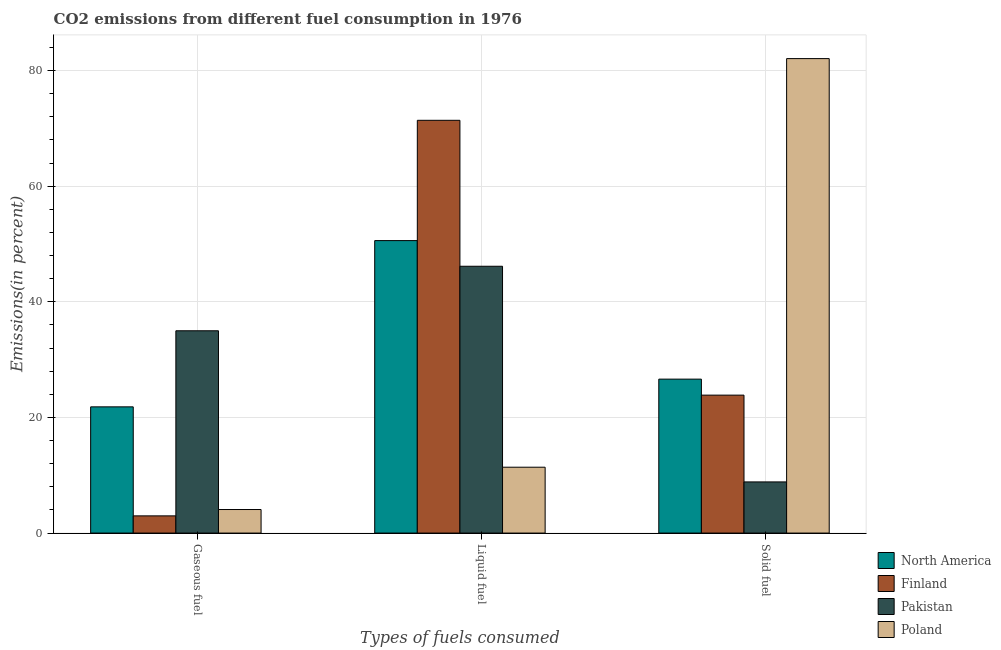Are the number of bars per tick equal to the number of legend labels?
Provide a short and direct response. Yes. What is the label of the 3rd group of bars from the left?
Provide a short and direct response. Solid fuel. What is the percentage of liquid fuel emission in Pakistan?
Keep it short and to the point. 46.15. Across all countries, what is the maximum percentage of solid fuel emission?
Your answer should be very brief. 82.06. Across all countries, what is the minimum percentage of liquid fuel emission?
Give a very brief answer. 11.39. What is the total percentage of gaseous fuel emission in the graph?
Your answer should be compact. 63.87. What is the difference between the percentage of gaseous fuel emission in Finland and that in North America?
Provide a succinct answer. -18.85. What is the difference between the percentage of solid fuel emission in Finland and the percentage of gaseous fuel emission in Poland?
Your response must be concise. 19.78. What is the average percentage of solid fuel emission per country?
Provide a short and direct response. 35.35. What is the difference between the percentage of solid fuel emission and percentage of liquid fuel emission in North America?
Offer a terse response. -23.96. What is the ratio of the percentage of solid fuel emission in Finland to that in Pakistan?
Offer a terse response. 2.7. What is the difference between the highest and the second highest percentage of liquid fuel emission?
Your response must be concise. 20.8. What is the difference between the highest and the lowest percentage of gaseous fuel emission?
Ensure brevity in your answer.  32.01. In how many countries, is the percentage of solid fuel emission greater than the average percentage of solid fuel emission taken over all countries?
Make the answer very short. 1. What does the 3rd bar from the right in Liquid fuel represents?
Keep it short and to the point. Finland. Are the values on the major ticks of Y-axis written in scientific E-notation?
Your answer should be very brief. No. Does the graph contain any zero values?
Provide a succinct answer. No. Does the graph contain grids?
Your answer should be compact. Yes. Where does the legend appear in the graph?
Your response must be concise. Bottom right. What is the title of the graph?
Provide a succinct answer. CO2 emissions from different fuel consumption in 1976. Does "Antigua and Barbuda" appear as one of the legend labels in the graph?
Provide a short and direct response. No. What is the label or title of the X-axis?
Offer a very short reply. Types of fuels consumed. What is the label or title of the Y-axis?
Your answer should be compact. Emissions(in percent). What is the Emissions(in percent) of North America in Gaseous fuel?
Your answer should be compact. 21.83. What is the Emissions(in percent) of Finland in Gaseous fuel?
Your response must be concise. 2.97. What is the Emissions(in percent) of Pakistan in Gaseous fuel?
Make the answer very short. 34.99. What is the Emissions(in percent) of Poland in Gaseous fuel?
Your response must be concise. 4.07. What is the Emissions(in percent) in North America in Liquid fuel?
Your answer should be compact. 50.58. What is the Emissions(in percent) in Finland in Liquid fuel?
Make the answer very short. 71.39. What is the Emissions(in percent) of Pakistan in Liquid fuel?
Your response must be concise. 46.15. What is the Emissions(in percent) of Poland in Liquid fuel?
Give a very brief answer. 11.39. What is the Emissions(in percent) of North America in Solid fuel?
Your answer should be compact. 26.62. What is the Emissions(in percent) in Finland in Solid fuel?
Offer a terse response. 23.86. What is the Emissions(in percent) in Pakistan in Solid fuel?
Your answer should be very brief. 8.85. What is the Emissions(in percent) in Poland in Solid fuel?
Offer a terse response. 82.06. Across all Types of fuels consumed, what is the maximum Emissions(in percent) in North America?
Give a very brief answer. 50.58. Across all Types of fuels consumed, what is the maximum Emissions(in percent) of Finland?
Offer a terse response. 71.39. Across all Types of fuels consumed, what is the maximum Emissions(in percent) of Pakistan?
Provide a succinct answer. 46.15. Across all Types of fuels consumed, what is the maximum Emissions(in percent) of Poland?
Your answer should be compact. 82.06. Across all Types of fuels consumed, what is the minimum Emissions(in percent) of North America?
Provide a succinct answer. 21.83. Across all Types of fuels consumed, what is the minimum Emissions(in percent) of Finland?
Give a very brief answer. 2.97. Across all Types of fuels consumed, what is the minimum Emissions(in percent) in Pakistan?
Offer a terse response. 8.85. Across all Types of fuels consumed, what is the minimum Emissions(in percent) of Poland?
Provide a succinct answer. 4.07. What is the total Emissions(in percent) in North America in the graph?
Your response must be concise. 99.04. What is the total Emissions(in percent) in Finland in the graph?
Offer a very short reply. 98.22. What is the total Emissions(in percent) in Pakistan in the graph?
Your response must be concise. 89.98. What is the total Emissions(in percent) of Poland in the graph?
Offer a terse response. 97.53. What is the difference between the Emissions(in percent) of North America in Gaseous fuel and that in Liquid fuel?
Your answer should be very brief. -28.75. What is the difference between the Emissions(in percent) of Finland in Gaseous fuel and that in Liquid fuel?
Keep it short and to the point. -68.41. What is the difference between the Emissions(in percent) of Pakistan in Gaseous fuel and that in Liquid fuel?
Your answer should be very brief. -11.16. What is the difference between the Emissions(in percent) in Poland in Gaseous fuel and that in Liquid fuel?
Provide a succinct answer. -7.32. What is the difference between the Emissions(in percent) in North America in Gaseous fuel and that in Solid fuel?
Offer a very short reply. -4.79. What is the difference between the Emissions(in percent) of Finland in Gaseous fuel and that in Solid fuel?
Your answer should be very brief. -20.88. What is the difference between the Emissions(in percent) of Pakistan in Gaseous fuel and that in Solid fuel?
Your response must be concise. 26.14. What is the difference between the Emissions(in percent) of Poland in Gaseous fuel and that in Solid fuel?
Keep it short and to the point. -77.99. What is the difference between the Emissions(in percent) of North America in Liquid fuel and that in Solid fuel?
Give a very brief answer. 23.96. What is the difference between the Emissions(in percent) of Finland in Liquid fuel and that in Solid fuel?
Your response must be concise. 47.53. What is the difference between the Emissions(in percent) of Pakistan in Liquid fuel and that in Solid fuel?
Keep it short and to the point. 37.3. What is the difference between the Emissions(in percent) in Poland in Liquid fuel and that in Solid fuel?
Your answer should be very brief. -70.67. What is the difference between the Emissions(in percent) of North America in Gaseous fuel and the Emissions(in percent) of Finland in Liquid fuel?
Your answer should be very brief. -49.56. What is the difference between the Emissions(in percent) of North America in Gaseous fuel and the Emissions(in percent) of Pakistan in Liquid fuel?
Offer a terse response. -24.32. What is the difference between the Emissions(in percent) in North America in Gaseous fuel and the Emissions(in percent) in Poland in Liquid fuel?
Your answer should be compact. 10.44. What is the difference between the Emissions(in percent) in Finland in Gaseous fuel and the Emissions(in percent) in Pakistan in Liquid fuel?
Your answer should be very brief. -43.17. What is the difference between the Emissions(in percent) in Finland in Gaseous fuel and the Emissions(in percent) in Poland in Liquid fuel?
Your answer should be very brief. -8.42. What is the difference between the Emissions(in percent) of Pakistan in Gaseous fuel and the Emissions(in percent) of Poland in Liquid fuel?
Give a very brief answer. 23.6. What is the difference between the Emissions(in percent) in North America in Gaseous fuel and the Emissions(in percent) in Finland in Solid fuel?
Your answer should be compact. -2.03. What is the difference between the Emissions(in percent) of North America in Gaseous fuel and the Emissions(in percent) of Pakistan in Solid fuel?
Give a very brief answer. 12.98. What is the difference between the Emissions(in percent) in North America in Gaseous fuel and the Emissions(in percent) in Poland in Solid fuel?
Offer a terse response. -60.23. What is the difference between the Emissions(in percent) in Finland in Gaseous fuel and the Emissions(in percent) in Pakistan in Solid fuel?
Provide a short and direct response. -5.87. What is the difference between the Emissions(in percent) in Finland in Gaseous fuel and the Emissions(in percent) in Poland in Solid fuel?
Offer a very short reply. -79.09. What is the difference between the Emissions(in percent) in Pakistan in Gaseous fuel and the Emissions(in percent) in Poland in Solid fuel?
Make the answer very short. -47.07. What is the difference between the Emissions(in percent) of North America in Liquid fuel and the Emissions(in percent) of Finland in Solid fuel?
Offer a very short reply. 26.73. What is the difference between the Emissions(in percent) in North America in Liquid fuel and the Emissions(in percent) in Pakistan in Solid fuel?
Make the answer very short. 41.74. What is the difference between the Emissions(in percent) in North America in Liquid fuel and the Emissions(in percent) in Poland in Solid fuel?
Make the answer very short. -31.48. What is the difference between the Emissions(in percent) in Finland in Liquid fuel and the Emissions(in percent) in Pakistan in Solid fuel?
Your response must be concise. 62.54. What is the difference between the Emissions(in percent) of Finland in Liquid fuel and the Emissions(in percent) of Poland in Solid fuel?
Make the answer very short. -10.67. What is the difference between the Emissions(in percent) in Pakistan in Liquid fuel and the Emissions(in percent) in Poland in Solid fuel?
Your answer should be compact. -35.91. What is the average Emissions(in percent) in North America per Types of fuels consumed?
Your response must be concise. 33.01. What is the average Emissions(in percent) in Finland per Types of fuels consumed?
Provide a succinct answer. 32.74. What is the average Emissions(in percent) in Pakistan per Types of fuels consumed?
Your response must be concise. 29.99. What is the average Emissions(in percent) in Poland per Types of fuels consumed?
Provide a succinct answer. 32.51. What is the difference between the Emissions(in percent) of North America and Emissions(in percent) of Finland in Gaseous fuel?
Ensure brevity in your answer.  18.85. What is the difference between the Emissions(in percent) in North America and Emissions(in percent) in Pakistan in Gaseous fuel?
Provide a succinct answer. -13.16. What is the difference between the Emissions(in percent) in North America and Emissions(in percent) in Poland in Gaseous fuel?
Offer a very short reply. 17.76. What is the difference between the Emissions(in percent) in Finland and Emissions(in percent) in Pakistan in Gaseous fuel?
Offer a terse response. -32.01. What is the difference between the Emissions(in percent) of Finland and Emissions(in percent) of Poland in Gaseous fuel?
Make the answer very short. -1.1. What is the difference between the Emissions(in percent) in Pakistan and Emissions(in percent) in Poland in Gaseous fuel?
Offer a terse response. 30.91. What is the difference between the Emissions(in percent) in North America and Emissions(in percent) in Finland in Liquid fuel?
Ensure brevity in your answer.  -20.8. What is the difference between the Emissions(in percent) in North America and Emissions(in percent) in Pakistan in Liquid fuel?
Your answer should be very brief. 4.44. What is the difference between the Emissions(in percent) in North America and Emissions(in percent) in Poland in Liquid fuel?
Ensure brevity in your answer.  39.19. What is the difference between the Emissions(in percent) of Finland and Emissions(in percent) of Pakistan in Liquid fuel?
Make the answer very short. 25.24. What is the difference between the Emissions(in percent) of Finland and Emissions(in percent) of Poland in Liquid fuel?
Your response must be concise. 60. What is the difference between the Emissions(in percent) of Pakistan and Emissions(in percent) of Poland in Liquid fuel?
Give a very brief answer. 34.76. What is the difference between the Emissions(in percent) of North America and Emissions(in percent) of Finland in Solid fuel?
Your answer should be compact. 2.77. What is the difference between the Emissions(in percent) of North America and Emissions(in percent) of Pakistan in Solid fuel?
Offer a terse response. 17.78. What is the difference between the Emissions(in percent) in North America and Emissions(in percent) in Poland in Solid fuel?
Your answer should be compact. -55.44. What is the difference between the Emissions(in percent) of Finland and Emissions(in percent) of Pakistan in Solid fuel?
Give a very brief answer. 15.01. What is the difference between the Emissions(in percent) in Finland and Emissions(in percent) in Poland in Solid fuel?
Your answer should be very brief. -58.2. What is the difference between the Emissions(in percent) of Pakistan and Emissions(in percent) of Poland in Solid fuel?
Your answer should be very brief. -73.21. What is the ratio of the Emissions(in percent) of North America in Gaseous fuel to that in Liquid fuel?
Provide a short and direct response. 0.43. What is the ratio of the Emissions(in percent) in Finland in Gaseous fuel to that in Liquid fuel?
Provide a succinct answer. 0.04. What is the ratio of the Emissions(in percent) of Pakistan in Gaseous fuel to that in Liquid fuel?
Offer a very short reply. 0.76. What is the ratio of the Emissions(in percent) of Poland in Gaseous fuel to that in Liquid fuel?
Keep it short and to the point. 0.36. What is the ratio of the Emissions(in percent) in North America in Gaseous fuel to that in Solid fuel?
Your response must be concise. 0.82. What is the ratio of the Emissions(in percent) in Finland in Gaseous fuel to that in Solid fuel?
Provide a short and direct response. 0.12. What is the ratio of the Emissions(in percent) of Pakistan in Gaseous fuel to that in Solid fuel?
Provide a succinct answer. 3.95. What is the ratio of the Emissions(in percent) of Poland in Gaseous fuel to that in Solid fuel?
Keep it short and to the point. 0.05. What is the ratio of the Emissions(in percent) in Finland in Liquid fuel to that in Solid fuel?
Offer a terse response. 2.99. What is the ratio of the Emissions(in percent) of Pakistan in Liquid fuel to that in Solid fuel?
Provide a short and direct response. 5.22. What is the ratio of the Emissions(in percent) in Poland in Liquid fuel to that in Solid fuel?
Give a very brief answer. 0.14. What is the difference between the highest and the second highest Emissions(in percent) of North America?
Your answer should be very brief. 23.96. What is the difference between the highest and the second highest Emissions(in percent) in Finland?
Offer a very short reply. 47.53. What is the difference between the highest and the second highest Emissions(in percent) of Pakistan?
Provide a succinct answer. 11.16. What is the difference between the highest and the second highest Emissions(in percent) in Poland?
Offer a terse response. 70.67. What is the difference between the highest and the lowest Emissions(in percent) in North America?
Make the answer very short. 28.75. What is the difference between the highest and the lowest Emissions(in percent) in Finland?
Provide a short and direct response. 68.41. What is the difference between the highest and the lowest Emissions(in percent) of Pakistan?
Your answer should be compact. 37.3. What is the difference between the highest and the lowest Emissions(in percent) of Poland?
Your response must be concise. 77.99. 